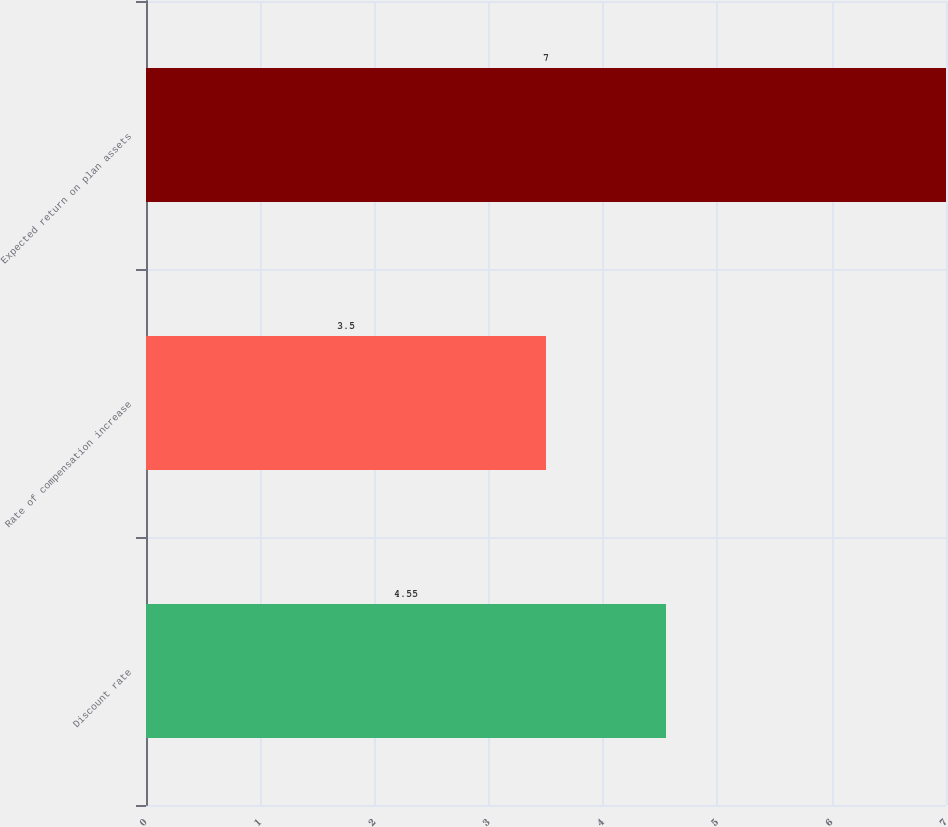<chart> <loc_0><loc_0><loc_500><loc_500><bar_chart><fcel>Discount rate<fcel>Rate of compensation increase<fcel>Expected return on plan assets<nl><fcel>4.55<fcel>3.5<fcel>7<nl></chart> 